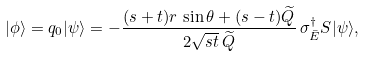<formula> <loc_0><loc_0><loc_500><loc_500>| \phi \rangle = q _ { 0 } | \psi \rangle = - \frac { ( s + t ) r \, \sin \theta + ( s - t ) \widetilde { Q } } { 2 \sqrt { s t } \, \widetilde { Q } } \, \sigma _ { \bar { E } } ^ { \dagger } S | \psi \rangle ,</formula> 